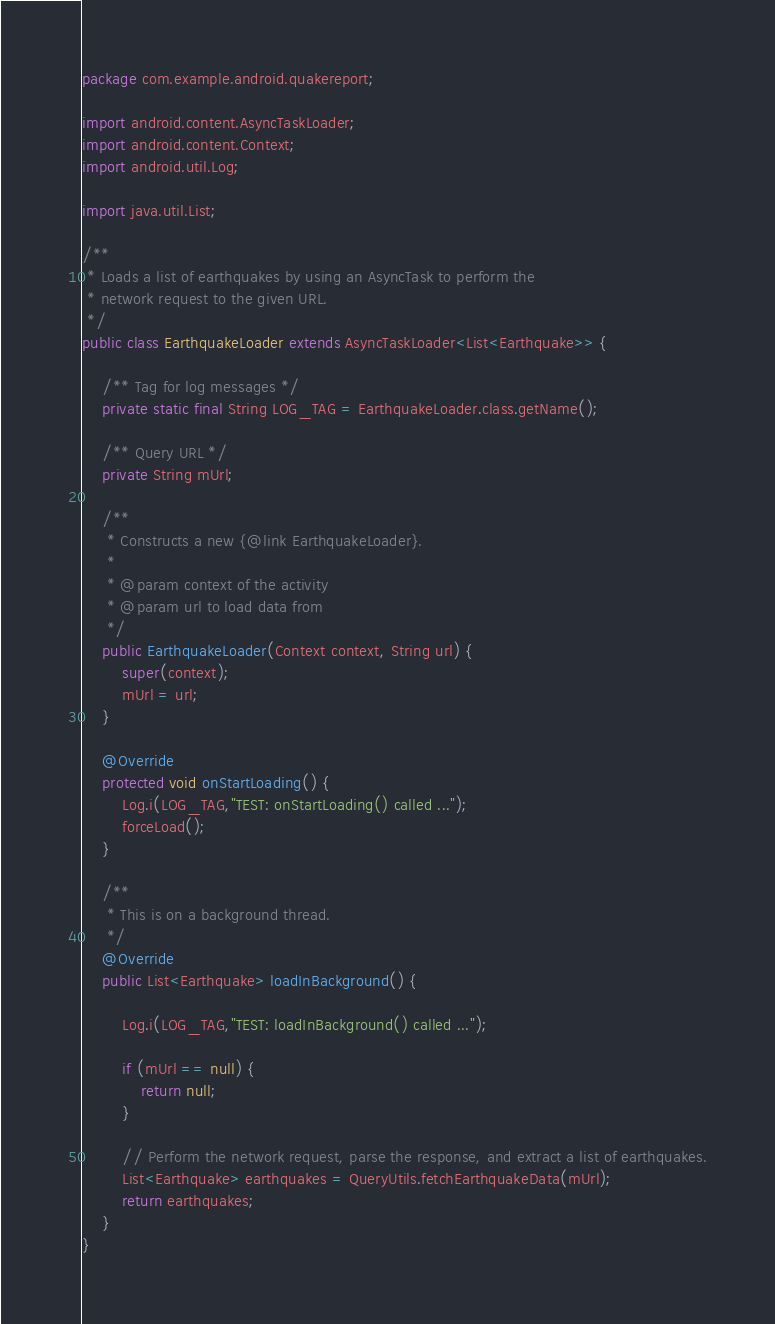<code> <loc_0><loc_0><loc_500><loc_500><_Java_>package com.example.android.quakereport;

import android.content.AsyncTaskLoader;
import android.content.Context;
import android.util.Log;

import java.util.List;

/**
 * Loads a list of earthquakes by using an AsyncTask to perform the
 * network request to the given URL.
 */
public class EarthquakeLoader extends AsyncTaskLoader<List<Earthquake>> {

    /** Tag for log messages */
    private static final String LOG_TAG = EarthquakeLoader.class.getName();

    /** Query URL */
    private String mUrl;

    /**
     * Constructs a new {@link EarthquakeLoader}.
     *
     * @param context of the activity
     * @param url to load data from
     */
    public EarthquakeLoader(Context context, String url) {
        super(context);
        mUrl = url;
    }

    @Override
    protected void onStartLoading() {
        Log.i(LOG_TAG,"TEST: onStartLoading() called ...");
        forceLoad();
    }

    /**
     * This is on a background thread.
     */
    @Override
    public List<Earthquake> loadInBackground() {

        Log.i(LOG_TAG,"TEST: loadInBackground() called ...");

        if (mUrl == null) {
            return null;
        }

        // Perform the network request, parse the response, and extract a list of earthquakes.
        List<Earthquake> earthquakes = QueryUtils.fetchEarthquakeData(mUrl);
        return earthquakes;
    }
}</code> 